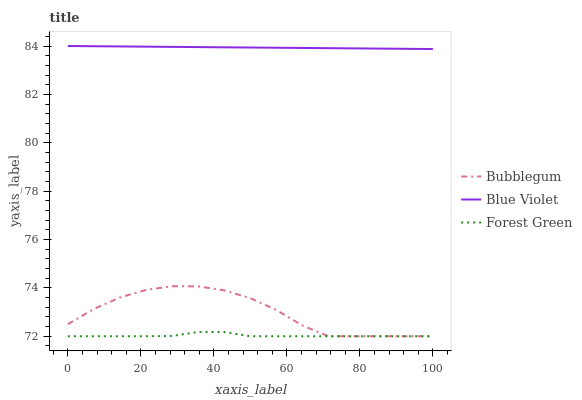Does Forest Green have the minimum area under the curve?
Answer yes or no. Yes. Does Blue Violet have the maximum area under the curve?
Answer yes or no. Yes. Does Bubblegum have the minimum area under the curve?
Answer yes or no. No. Does Bubblegum have the maximum area under the curve?
Answer yes or no. No. Is Blue Violet the smoothest?
Answer yes or no. Yes. Is Bubblegum the roughest?
Answer yes or no. Yes. Is Bubblegum the smoothest?
Answer yes or no. No. Is Blue Violet the roughest?
Answer yes or no. No. Does Blue Violet have the lowest value?
Answer yes or no. No. Does Blue Violet have the highest value?
Answer yes or no. Yes. Does Bubblegum have the highest value?
Answer yes or no. No. Is Forest Green less than Blue Violet?
Answer yes or no. Yes. Is Blue Violet greater than Bubblegum?
Answer yes or no. Yes. Does Bubblegum intersect Forest Green?
Answer yes or no. Yes. Is Bubblegum less than Forest Green?
Answer yes or no. No. Is Bubblegum greater than Forest Green?
Answer yes or no. No. Does Forest Green intersect Blue Violet?
Answer yes or no. No. 